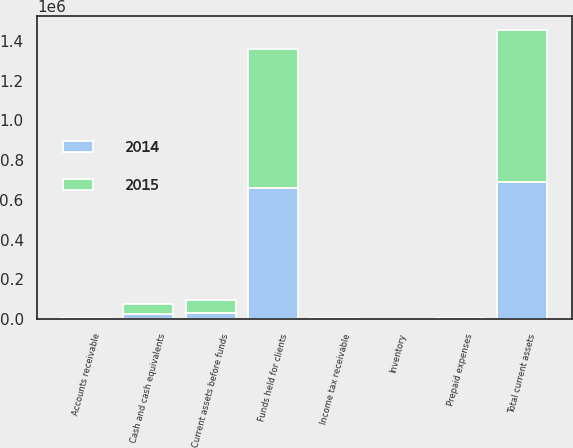Convert chart. <chart><loc_0><loc_0><loc_500><loc_500><stacked_bar_chart><ecel><fcel>Cash and cash equivalents<fcel>Accounts receivable<fcel>Prepaid expenses<fcel>Inventory<fcel>Income tax receivable<fcel>Current assets before funds<fcel>Funds held for clients<fcel>Total current assets<nl><fcel>2015<fcel>50714<fcel>2354<fcel>3531<fcel>1093<fcel>6743<fcel>64435<fcel>696703<fcel>761138<nl><fcel>2014<fcel>25144<fcel>2794<fcel>1952<fcel>195<fcel>935<fcel>31391<fcel>660557<fcel>691948<nl></chart> 